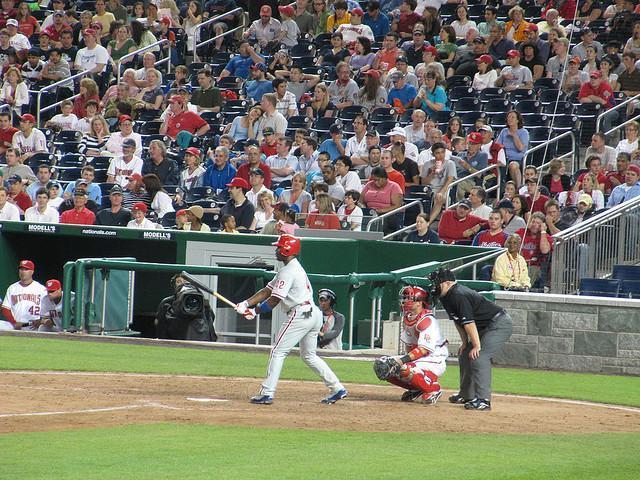How many people are there?
Give a very brief answer. 5. 